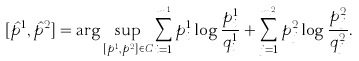Convert formula to latex. <formula><loc_0><loc_0><loc_500><loc_500>[ \hat { p } ^ { 1 } , \hat { p } ^ { 2 } ] = \arg \sup _ { [ p ^ { 1 } , p ^ { 2 } ] \in C } \sum _ { i = 1 } ^ { m ^ { 1 } } p ^ { 1 } _ { i } \log \frac { p ^ { 1 } _ { i } } { q ^ { 1 } _ { i } } + \sum _ { j = 1 } ^ { m ^ { 2 } } p ^ { 2 } _ { j } \log \frac { p ^ { 2 } _ { j } } { q ^ { 2 } _ { j } } .</formula> 